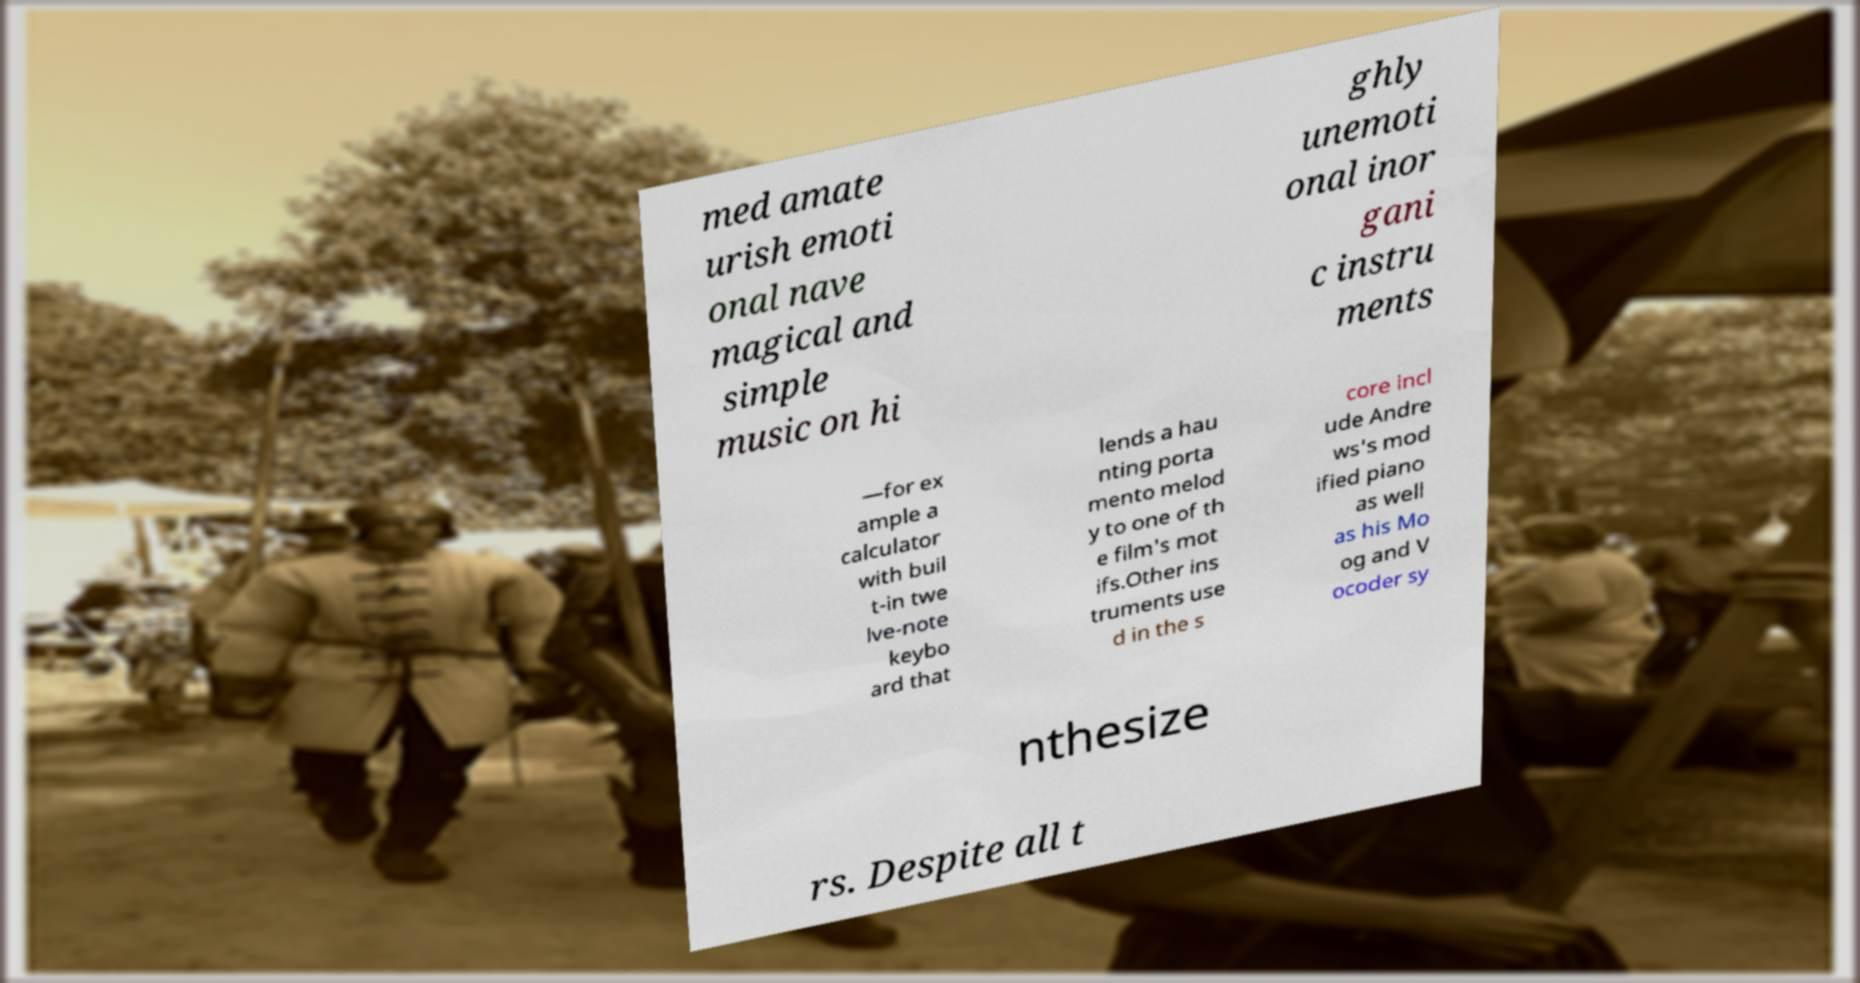Please identify and transcribe the text found in this image. med amate urish emoti onal nave magical and simple music on hi ghly unemoti onal inor gani c instru ments —for ex ample a calculator with buil t-in twe lve-note keybo ard that lends a hau nting porta mento melod y to one of th e film's mot ifs.Other ins truments use d in the s core incl ude Andre ws's mod ified piano as well as his Mo og and V ocoder sy nthesize rs. Despite all t 